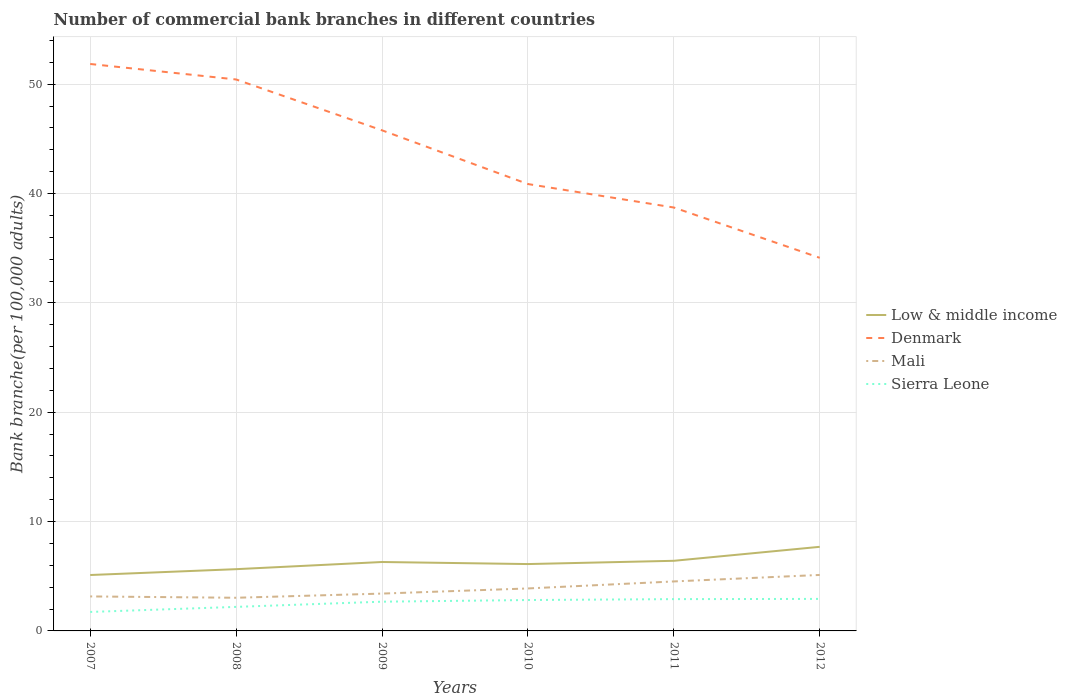How many different coloured lines are there?
Ensure brevity in your answer.  4. Does the line corresponding to Denmark intersect with the line corresponding to Sierra Leone?
Offer a terse response. No. Across all years, what is the maximum number of commercial bank branches in Denmark?
Your answer should be very brief. 34.12. In which year was the number of commercial bank branches in Low & middle income maximum?
Your response must be concise. 2007. What is the total number of commercial bank branches in Mali in the graph?
Your answer should be compact. -1.37. What is the difference between the highest and the second highest number of commercial bank branches in Sierra Leone?
Your answer should be very brief. 1.19. Is the number of commercial bank branches in Denmark strictly greater than the number of commercial bank branches in Low & middle income over the years?
Your answer should be very brief. No. How many lines are there?
Make the answer very short. 4. Are the values on the major ticks of Y-axis written in scientific E-notation?
Give a very brief answer. No. Does the graph contain any zero values?
Your answer should be very brief. No. How many legend labels are there?
Your answer should be very brief. 4. What is the title of the graph?
Provide a short and direct response. Number of commercial bank branches in different countries. Does "Cambodia" appear as one of the legend labels in the graph?
Your answer should be compact. No. What is the label or title of the X-axis?
Your response must be concise. Years. What is the label or title of the Y-axis?
Your answer should be compact. Bank branche(per 100,0 adults). What is the Bank branche(per 100,000 adults) of Low & middle income in 2007?
Your answer should be compact. 5.11. What is the Bank branche(per 100,000 adults) of Denmark in 2007?
Make the answer very short. 51.85. What is the Bank branche(per 100,000 adults) in Mali in 2007?
Give a very brief answer. 3.15. What is the Bank branche(per 100,000 adults) of Sierra Leone in 2007?
Offer a very short reply. 1.73. What is the Bank branche(per 100,000 adults) of Low & middle income in 2008?
Provide a short and direct response. 5.65. What is the Bank branche(per 100,000 adults) in Denmark in 2008?
Offer a very short reply. 50.43. What is the Bank branche(per 100,000 adults) in Mali in 2008?
Your answer should be very brief. 3.03. What is the Bank branche(per 100,000 adults) of Sierra Leone in 2008?
Offer a very short reply. 2.2. What is the Bank branche(per 100,000 adults) in Low & middle income in 2009?
Ensure brevity in your answer.  6.3. What is the Bank branche(per 100,000 adults) in Denmark in 2009?
Keep it short and to the point. 45.78. What is the Bank branche(per 100,000 adults) of Mali in 2009?
Offer a terse response. 3.42. What is the Bank branche(per 100,000 adults) in Sierra Leone in 2009?
Provide a succinct answer. 2.67. What is the Bank branche(per 100,000 adults) of Low & middle income in 2010?
Offer a very short reply. 6.11. What is the Bank branche(per 100,000 adults) of Denmark in 2010?
Make the answer very short. 40.87. What is the Bank branche(per 100,000 adults) in Mali in 2010?
Give a very brief answer. 3.88. What is the Bank branche(per 100,000 adults) in Sierra Leone in 2010?
Your answer should be very brief. 2.83. What is the Bank branche(per 100,000 adults) of Low & middle income in 2011?
Your answer should be very brief. 6.41. What is the Bank branche(per 100,000 adults) of Denmark in 2011?
Offer a terse response. 38.72. What is the Bank branche(per 100,000 adults) in Mali in 2011?
Your answer should be very brief. 4.52. What is the Bank branche(per 100,000 adults) of Sierra Leone in 2011?
Keep it short and to the point. 2.91. What is the Bank branche(per 100,000 adults) of Low & middle income in 2012?
Provide a succinct answer. 7.69. What is the Bank branche(per 100,000 adults) in Denmark in 2012?
Provide a short and direct response. 34.12. What is the Bank branche(per 100,000 adults) in Mali in 2012?
Your response must be concise. 5.12. What is the Bank branche(per 100,000 adults) in Sierra Leone in 2012?
Ensure brevity in your answer.  2.93. Across all years, what is the maximum Bank branche(per 100,000 adults) in Low & middle income?
Make the answer very short. 7.69. Across all years, what is the maximum Bank branche(per 100,000 adults) in Denmark?
Your response must be concise. 51.85. Across all years, what is the maximum Bank branche(per 100,000 adults) in Mali?
Provide a succinct answer. 5.12. Across all years, what is the maximum Bank branche(per 100,000 adults) of Sierra Leone?
Offer a very short reply. 2.93. Across all years, what is the minimum Bank branche(per 100,000 adults) of Low & middle income?
Your answer should be compact. 5.11. Across all years, what is the minimum Bank branche(per 100,000 adults) of Denmark?
Give a very brief answer. 34.12. Across all years, what is the minimum Bank branche(per 100,000 adults) of Mali?
Offer a very short reply. 3.03. Across all years, what is the minimum Bank branche(per 100,000 adults) of Sierra Leone?
Your answer should be compact. 1.73. What is the total Bank branche(per 100,000 adults) in Low & middle income in the graph?
Offer a terse response. 37.28. What is the total Bank branche(per 100,000 adults) in Denmark in the graph?
Make the answer very short. 261.77. What is the total Bank branche(per 100,000 adults) of Mali in the graph?
Make the answer very short. 23.13. What is the total Bank branche(per 100,000 adults) of Sierra Leone in the graph?
Provide a succinct answer. 15.27. What is the difference between the Bank branche(per 100,000 adults) in Low & middle income in 2007 and that in 2008?
Offer a terse response. -0.53. What is the difference between the Bank branche(per 100,000 adults) in Denmark in 2007 and that in 2008?
Your response must be concise. 1.42. What is the difference between the Bank branche(per 100,000 adults) in Mali in 2007 and that in 2008?
Your answer should be very brief. 0.12. What is the difference between the Bank branche(per 100,000 adults) in Sierra Leone in 2007 and that in 2008?
Make the answer very short. -0.46. What is the difference between the Bank branche(per 100,000 adults) in Low & middle income in 2007 and that in 2009?
Your answer should be compact. -1.19. What is the difference between the Bank branche(per 100,000 adults) in Denmark in 2007 and that in 2009?
Offer a very short reply. 6.07. What is the difference between the Bank branche(per 100,000 adults) of Mali in 2007 and that in 2009?
Ensure brevity in your answer.  -0.26. What is the difference between the Bank branche(per 100,000 adults) of Sierra Leone in 2007 and that in 2009?
Your answer should be very brief. -0.94. What is the difference between the Bank branche(per 100,000 adults) in Low & middle income in 2007 and that in 2010?
Your answer should be compact. -1. What is the difference between the Bank branche(per 100,000 adults) in Denmark in 2007 and that in 2010?
Your answer should be compact. 10.98. What is the difference between the Bank branche(per 100,000 adults) in Mali in 2007 and that in 2010?
Ensure brevity in your answer.  -0.73. What is the difference between the Bank branche(per 100,000 adults) in Sierra Leone in 2007 and that in 2010?
Provide a succinct answer. -1.09. What is the difference between the Bank branche(per 100,000 adults) of Low & middle income in 2007 and that in 2011?
Your answer should be compact. -1.3. What is the difference between the Bank branche(per 100,000 adults) in Denmark in 2007 and that in 2011?
Your answer should be very brief. 13.13. What is the difference between the Bank branche(per 100,000 adults) of Mali in 2007 and that in 2011?
Your answer should be compact. -1.37. What is the difference between the Bank branche(per 100,000 adults) in Sierra Leone in 2007 and that in 2011?
Ensure brevity in your answer.  -1.17. What is the difference between the Bank branche(per 100,000 adults) in Low & middle income in 2007 and that in 2012?
Provide a succinct answer. -2.58. What is the difference between the Bank branche(per 100,000 adults) in Denmark in 2007 and that in 2012?
Make the answer very short. 17.73. What is the difference between the Bank branche(per 100,000 adults) of Mali in 2007 and that in 2012?
Keep it short and to the point. -1.97. What is the difference between the Bank branche(per 100,000 adults) in Sierra Leone in 2007 and that in 2012?
Ensure brevity in your answer.  -1.19. What is the difference between the Bank branche(per 100,000 adults) in Low & middle income in 2008 and that in 2009?
Offer a terse response. -0.66. What is the difference between the Bank branche(per 100,000 adults) of Denmark in 2008 and that in 2009?
Keep it short and to the point. 4.65. What is the difference between the Bank branche(per 100,000 adults) in Mali in 2008 and that in 2009?
Provide a short and direct response. -0.38. What is the difference between the Bank branche(per 100,000 adults) of Sierra Leone in 2008 and that in 2009?
Make the answer very short. -0.48. What is the difference between the Bank branche(per 100,000 adults) of Low & middle income in 2008 and that in 2010?
Give a very brief answer. -0.47. What is the difference between the Bank branche(per 100,000 adults) of Denmark in 2008 and that in 2010?
Provide a succinct answer. 9.56. What is the difference between the Bank branche(per 100,000 adults) in Mali in 2008 and that in 2010?
Your answer should be compact. -0.85. What is the difference between the Bank branche(per 100,000 adults) in Sierra Leone in 2008 and that in 2010?
Keep it short and to the point. -0.63. What is the difference between the Bank branche(per 100,000 adults) of Low & middle income in 2008 and that in 2011?
Keep it short and to the point. -0.76. What is the difference between the Bank branche(per 100,000 adults) in Denmark in 2008 and that in 2011?
Your response must be concise. 11.71. What is the difference between the Bank branche(per 100,000 adults) in Mali in 2008 and that in 2011?
Give a very brief answer. -1.49. What is the difference between the Bank branche(per 100,000 adults) of Sierra Leone in 2008 and that in 2011?
Offer a terse response. -0.71. What is the difference between the Bank branche(per 100,000 adults) of Low & middle income in 2008 and that in 2012?
Offer a terse response. -2.04. What is the difference between the Bank branche(per 100,000 adults) in Denmark in 2008 and that in 2012?
Ensure brevity in your answer.  16.31. What is the difference between the Bank branche(per 100,000 adults) of Mali in 2008 and that in 2012?
Offer a terse response. -2.09. What is the difference between the Bank branche(per 100,000 adults) in Sierra Leone in 2008 and that in 2012?
Provide a short and direct response. -0.73. What is the difference between the Bank branche(per 100,000 adults) in Low & middle income in 2009 and that in 2010?
Give a very brief answer. 0.19. What is the difference between the Bank branche(per 100,000 adults) of Denmark in 2009 and that in 2010?
Offer a very short reply. 4.91. What is the difference between the Bank branche(per 100,000 adults) of Mali in 2009 and that in 2010?
Your response must be concise. -0.47. What is the difference between the Bank branche(per 100,000 adults) in Sierra Leone in 2009 and that in 2010?
Provide a short and direct response. -0.15. What is the difference between the Bank branche(per 100,000 adults) in Low & middle income in 2009 and that in 2011?
Provide a succinct answer. -0.11. What is the difference between the Bank branche(per 100,000 adults) of Denmark in 2009 and that in 2011?
Give a very brief answer. 7.06. What is the difference between the Bank branche(per 100,000 adults) in Mali in 2009 and that in 2011?
Your answer should be very brief. -1.11. What is the difference between the Bank branche(per 100,000 adults) in Sierra Leone in 2009 and that in 2011?
Your response must be concise. -0.23. What is the difference between the Bank branche(per 100,000 adults) of Low & middle income in 2009 and that in 2012?
Your answer should be very brief. -1.39. What is the difference between the Bank branche(per 100,000 adults) of Denmark in 2009 and that in 2012?
Provide a succinct answer. 11.66. What is the difference between the Bank branche(per 100,000 adults) of Mali in 2009 and that in 2012?
Your answer should be very brief. -1.7. What is the difference between the Bank branche(per 100,000 adults) of Sierra Leone in 2009 and that in 2012?
Make the answer very short. -0.25. What is the difference between the Bank branche(per 100,000 adults) of Low & middle income in 2010 and that in 2011?
Give a very brief answer. -0.3. What is the difference between the Bank branche(per 100,000 adults) of Denmark in 2010 and that in 2011?
Keep it short and to the point. 2.15. What is the difference between the Bank branche(per 100,000 adults) in Mali in 2010 and that in 2011?
Your answer should be compact. -0.64. What is the difference between the Bank branche(per 100,000 adults) in Sierra Leone in 2010 and that in 2011?
Provide a short and direct response. -0.08. What is the difference between the Bank branche(per 100,000 adults) in Low & middle income in 2010 and that in 2012?
Your answer should be very brief. -1.58. What is the difference between the Bank branche(per 100,000 adults) in Denmark in 2010 and that in 2012?
Make the answer very short. 6.75. What is the difference between the Bank branche(per 100,000 adults) of Mali in 2010 and that in 2012?
Give a very brief answer. -1.24. What is the difference between the Bank branche(per 100,000 adults) of Sierra Leone in 2010 and that in 2012?
Offer a terse response. -0.1. What is the difference between the Bank branche(per 100,000 adults) in Low & middle income in 2011 and that in 2012?
Offer a very short reply. -1.28. What is the difference between the Bank branche(per 100,000 adults) in Denmark in 2011 and that in 2012?
Give a very brief answer. 4.6. What is the difference between the Bank branche(per 100,000 adults) of Mali in 2011 and that in 2012?
Provide a succinct answer. -0.59. What is the difference between the Bank branche(per 100,000 adults) in Sierra Leone in 2011 and that in 2012?
Your answer should be compact. -0.02. What is the difference between the Bank branche(per 100,000 adults) of Low & middle income in 2007 and the Bank branche(per 100,000 adults) of Denmark in 2008?
Your response must be concise. -45.32. What is the difference between the Bank branche(per 100,000 adults) of Low & middle income in 2007 and the Bank branche(per 100,000 adults) of Mali in 2008?
Your response must be concise. 2.08. What is the difference between the Bank branche(per 100,000 adults) in Low & middle income in 2007 and the Bank branche(per 100,000 adults) in Sierra Leone in 2008?
Your answer should be very brief. 2.91. What is the difference between the Bank branche(per 100,000 adults) of Denmark in 2007 and the Bank branche(per 100,000 adults) of Mali in 2008?
Offer a terse response. 48.82. What is the difference between the Bank branche(per 100,000 adults) of Denmark in 2007 and the Bank branche(per 100,000 adults) of Sierra Leone in 2008?
Offer a terse response. 49.65. What is the difference between the Bank branche(per 100,000 adults) in Mali in 2007 and the Bank branche(per 100,000 adults) in Sierra Leone in 2008?
Offer a very short reply. 0.96. What is the difference between the Bank branche(per 100,000 adults) in Low & middle income in 2007 and the Bank branche(per 100,000 adults) in Denmark in 2009?
Give a very brief answer. -40.67. What is the difference between the Bank branche(per 100,000 adults) in Low & middle income in 2007 and the Bank branche(per 100,000 adults) in Mali in 2009?
Provide a short and direct response. 1.7. What is the difference between the Bank branche(per 100,000 adults) of Low & middle income in 2007 and the Bank branche(per 100,000 adults) of Sierra Leone in 2009?
Your answer should be very brief. 2.44. What is the difference between the Bank branche(per 100,000 adults) in Denmark in 2007 and the Bank branche(per 100,000 adults) in Mali in 2009?
Your response must be concise. 48.43. What is the difference between the Bank branche(per 100,000 adults) in Denmark in 2007 and the Bank branche(per 100,000 adults) in Sierra Leone in 2009?
Offer a very short reply. 49.18. What is the difference between the Bank branche(per 100,000 adults) of Mali in 2007 and the Bank branche(per 100,000 adults) of Sierra Leone in 2009?
Provide a short and direct response. 0.48. What is the difference between the Bank branche(per 100,000 adults) of Low & middle income in 2007 and the Bank branche(per 100,000 adults) of Denmark in 2010?
Offer a very short reply. -35.76. What is the difference between the Bank branche(per 100,000 adults) of Low & middle income in 2007 and the Bank branche(per 100,000 adults) of Mali in 2010?
Offer a terse response. 1.23. What is the difference between the Bank branche(per 100,000 adults) in Low & middle income in 2007 and the Bank branche(per 100,000 adults) in Sierra Leone in 2010?
Make the answer very short. 2.29. What is the difference between the Bank branche(per 100,000 adults) in Denmark in 2007 and the Bank branche(per 100,000 adults) in Mali in 2010?
Keep it short and to the point. 47.96. What is the difference between the Bank branche(per 100,000 adults) in Denmark in 2007 and the Bank branche(per 100,000 adults) in Sierra Leone in 2010?
Offer a terse response. 49.02. What is the difference between the Bank branche(per 100,000 adults) in Mali in 2007 and the Bank branche(per 100,000 adults) in Sierra Leone in 2010?
Provide a succinct answer. 0.33. What is the difference between the Bank branche(per 100,000 adults) in Low & middle income in 2007 and the Bank branche(per 100,000 adults) in Denmark in 2011?
Your response must be concise. -33.61. What is the difference between the Bank branche(per 100,000 adults) in Low & middle income in 2007 and the Bank branche(per 100,000 adults) in Mali in 2011?
Your response must be concise. 0.59. What is the difference between the Bank branche(per 100,000 adults) in Low & middle income in 2007 and the Bank branche(per 100,000 adults) in Sierra Leone in 2011?
Keep it short and to the point. 2.2. What is the difference between the Bank branche(per 100,000 adults) in Denmark in 2007 and the Bank branche(per 100,000 adults) in Mali in 2011?
Provide a short and direct response. 47.32. What is the difference between the Bank branche(per 100,000 adults) of Denmark in 2007 and the Bank branche(per 100,000 adults) of Sierra Leone in 2011?
Offer a terse response. 48.94. What is the difference between the Bank branche(per 100,000 adults) of Mali in 2007 and the Bank branche(per 100,000 adults) of Sierra Leone in 2011?
Your answer should be very brief. 0.25. What is the difference between the Bank branche(per 100,000 adults) in Low & middle income in 2007 and the Bank branche(per 100,000 adults) in Denmark in 2012?
Give a very brief answer. -29.01. What is the difference between the Bank branche(per 100,000 adults) of Low & middle income in 2007 and the Bank branche(per 100,000 adults) of Mali in 2012?
Offer a terse response. -0.01. What is the difference between the Bank branche(per 100,000 adults) in Low & middle income in 2007 and the Bank branche(per 100,000 adults) in Sierra Leone in 2012?
Your response must be concise. 2.18. What is the difference between the Bank branche(per 100,000 adults) in Denmark in 2007 and the Bank branche(per 100,000 adults) in Mali in 2012?
Your response must be concise. 46.73. What is the difference between the Bank branche(per 100,000 adults) of Denmark in 2007 and the Bank branche(per 100,000 adults) of Sierra Leone in 2012?
Your answer should be compact. 48.92. What is the difference between the Bank branche(per 100,000 adults) in Mali in 2007 and the Bank branche(per 100,000 adults) in Sierra Leone in 2012?
Offer a terse response. 0.23. What is the difference between the Bank branche(per 100,000 adults) in Low & middle income in 2008 and the Bank branche(per 100,000 adults) in Denmark in 2009?
Keep it short and to the point. -40.13. What is the difference between the Bank branche(per 100,000 adults) of Low & middle income in 2008 and the Bank branche(per 100,000 adults) of Mali in 2009?
Keep it short and to the point. 2.23. What is the difference between the Bank branche(per 100,000 adults) of Low & middle income in 2008 and the Bank branche(per 100,000 adults) of Sierra Leone in 2009?
Your answer should be compact. 2.97. What is the difference between the Bank branche(per 100,000 adults) in Denmark in 2008 and the Bank branche(per 100,000 adults) in Mali in 2009?
Make the answer very short. 47.02. What is the difference between the Bank branche(per 100,000 adults) of Denmark in 2008 and the Bank branche(per 100,000 adults) of Sierra Leone in 2009?
Give a very brief answer. 47.76. What is the difference between the Bank branche(per 100,000 adults) in Mali in 2008 and the Bank branche(per 100,000 adults) in Sierra Leone in 2009?
Ensure brevity in your answer.  0.36. What is the difference between the Bank branche(per 100,000 adults) of Low & middle income in 2008 and the Bank branche(per 100,000 adults) of Denmark in 2010?
Your answer should be compact. -35.22. What is the difference between the Bank branche(per 100,000 adults) of Low & middle income in 2008 and the Bank branche(per 100,000 adults) of Mali in 2010?
Make the answer very short. 1.76. What is the difference between the Bank branche(per 100,000 adults) of Low & middle income in 2008 and the Bank branche(per 100,000 adults) of Sierra Leone in 2010?
Your answer should be compact. 2.82. What is the difference between the Bank branche(per 100,000 adults) in Denmark in 2008 and the Bank branche(per 100,000 adults) in Mali in 2010?
Provide a short and direct response. 46.55. What is the difference between the Bank branche(per 100,000 adults) in Denmark in 2008 and the Bank branche(per 100,000 adults) in Sierra Leone in 2010?
Make the answer very short. 47.61. What is the difference between the Bank branche(per 100,000 adults) of Mali in 2008 and the Bank branche(per 100,000 adults) of Sierra Leone in 2010?
Your answer should be compact. 0.21. What is the difference between the Bank branche(per 100,000 adults) in Low & middle income in 2008 and the Bank branche(per 100,000 adults) in Denmark in 2011?
Keep it short and to the point. -33.07. What is the difference between the Bank branche(per 100,000 adults) of Low & middle income in 2008 and the Bank branche(per 100,000 adults) of Mali in 2011?
Your response must be concise. 1.12. What is the difference between the Bank branche(per 100,000 adults) of Low & middle income in 2008 and the Bank branche(per 100,000 adults) of Sierra Leone in 2011?
Provide a succinct answer. 2.74. What is the difference between the Bank branche(per 100,000 adults) of Denmark in 2008 and the Bank branche(per 100,000 adults) of Mali in 2011?
Offer a terse response. 45.91. What is the difference between the Bank branche(per 100,000 adults) in Denmark in 2008 and the Bank branche(per 100,000 adults) in Sierra Leone in 2011?
Your answer should be very brief. 47.52. What is the difference between the Bank branche(per 100,000 adults) of Mali in 2008 and the Bank branche(per 100,000 adults) of Sierra Leone in 2011?
Offer a terse response. 0.12. What is the difference between the Bank branche(per 100,000 adults) in Low & middle income in 2008 and the Bank branche(per 100,000 adults) in Denmark in 2012?
Give a very brief answer. -28.47. What is the difference between the Bank branche(per 100,000 adults) in Low & middle income in 2008 and the Bank branche(per 100,000 adults) in Mali in 2012?
Your answer should be compact. 0.53. What is the difference between the Bank branche(per 100,000 adults) of Low & middle income in 2008 and the Bank branche(per 100,000 adults) of Sierra Leone in 2012?
Your response must be concise. 2.72. What is the difference between the Bank branche(per 100,000 adults) of Denmark in 2008 and the Bank branche(per 100,000 adults) of Mali in 2012?
Provide a succinct answer. 45.31. What is the difference between the Bank branche(per 100,000 adults) of Denmark in 2008 and the Bank branche(per 100,000 adults) of Sierra Leone in 2012?
Make the answer very short. 47.5. What is the difference between the Bank branche(per 100,000 adults) in Mali in 2008 and the Bank branche(per 100,000 adults) in Sierra Leone in 2012?
Your answer should be compact. 0.1. What is the difference between the Bank branche(per 100,000 adults) in Low & middle income in 2009 and the Bank branche(per 100,000 adults) in Denmark in 2010?
Ensure brevity in your answer.  -34.57. What is the difference between the Bank branche(per 100,000 adults) in Low & middle income in 2009 and the Bank branche(per 100,000 adults) in Mali in 2010?
Ensure brevity in your answer.  2.42. What is the difference between the Bank branche(per 100,000 adults) in Low & middle income in 2009 and the Bank branche(per 100,000 adults) in Sierra Leone in 2010?
Your answer should be compact. 3.48. What is the difference between the Bank branche(per 100,000 adults) in Denmark in 2009 and the Bank branche(per 100,000 adults) in Mali in 2010?
Offer a terse response. 41.9. What is the difference between the Bank branche(per 100,000 adults) in Denmark in 2009 and the Bank branche(per 100,000 adults) in Sierra Leone in 2010?
Ensure brevity in your answer.  42.96. What is the difference between the Bank branche(per 100,000 adults) of Mali in 2009 and the Bank branche(per 100,000 adults) of Sierra Leone in 2010?
Provide a succinct answer. 0.59. What is the difference between the Bank branche(per 100,000 adults) in Low & middle income in 2009 and the Bank branche(per 100,000 adults) in Denmark in 2011?
Make the answer very short. -32.42. What is the difference between the Bank branche(per 100,000 adults) of Low & middle income in 2009 and the Bank branche(per 100,000 adults) of Mali in 2011?
Your answer should be compact. 1.78. What is the difference between the Bank branche(per 100,000 adults) in Low & middle income in 2009 and the Bank branche(per 100,000 adults) in Sierra Leone in 2011?
Provide a succinct answer. 3.39. What is the difference between the Bank branche(per 100,000 adults) of Denmark in 2009 and the Bank branche(per 100,000 adults) of Mali in 2011?
Your answer should be very brief. 41.26. What is the difference between the Bank branche(per 100,000 adults) of Denmark in 2009 and the Bank branche(per 100,000 adults) of Sierra Leone in 2011?
Give a very brief answer. 42.87. What is the difference between the Bank branche(per 100,000 adults) of Mali in 2009 and the Bank branche(per 100,000 adults) of Sierra Leone in 2011?
Keep it short and to the point. 0.51. What is the difference between the Bank branche(per 100,000 adults) of Low & middle income in 2009 and the Bank branche(per 100,000 adults) of Denmark in 2012?
Provide a short and direct response. -27.82. What is the difference between the Bank branche(per 100,000 adults) of Low & middle income in 2009 and the Bank branche(per 100,000 adults) of Mali in 2012?
Keep it short and to the point. 1.18. What is the difference between the Bank branche(per 100,000 adults) of Low & middle income in 2009 and the Bank branche(per 100,000 adults) of Sierra Leone in 2012?
Your response must be concise. 3.37. What is the difference between the Bank branche(per 100,000 adults) of Denmark in 2009 and the Bank branche(per 100,000 adults) of Mali in 2012?
Offer a very short reply. 40.66. What is the difference between the Bank branche(per 100,000 adults) of Denmark in 2009 and the Bank branche(per 100,000 adults) of Sierra Leone in 2012?
Provide a short and direct response. 42.85. What is the difference between the Bank branche(per 100,000 adults) in Mali in 2009 and the Bank branche(per 100,000 adults) in Sierra Leone in 2012?
Give a very brief answer. 0.49. What is the difference between the Bank branche(per 100,000 adults) in Low & middle income in 2010 and the Bank branche(per 100,000 adults) in Denmark in 2011?
Your answer should be compact. -32.61. What is the difference between the Bank branche(per 100,000 adults) in Low & middle income in 2010 and the Bank branche(per 100,000 adults) in Mali in 2011?
Keep it short and to the point. 1.59. What is the difference between the Bank branche(per 100,000 adults) in Low & middle income in 2010 and the Bank branche(per 100,000 adults) in Sierra Leone in 2011?
Your answer should be very brief. 3.21. What is the difference between the Bank branche(per 100,000 adults) in Denmark in 2010 and the Bank branche(per 100,000 adults) in Mali in 2011?
Keep it short and to the point. 36.34. What is the difference between the Bank branche(per 100,000 adults) of Denmark in 2010 and the Bank branche(per 100,000 adults) of Sierra Leone in 2011?
Provide a succinct answer. 37.96. What is the difference between the Bank branche(per 100,000 adults) in Mali in 2010 and the Bank branche(per 100,000 adults) in Sierra Leone in 2011?
Your answer should be compact. 0.98. What is the difference between the Bank branche(per 100,000 adults) of Low & middle income in 2010 and the Bank branche(per 100,000 adults) of Denmark in 2012?
Make the answer very short. -28.01. What is the difference between the Bank branche(per 100,000 adults) of Low & middle income in 2010 and the Bank branche(per 100,000 adults) of Sierra Leone in 2012?
Keep it short and to the point. 3.19. What is the difference between the Bank branche(per 100,000 adults) of Denmark in 2010 and the Bank branche(per 100,000 adults) of Mali in 2012?
Your answer should be compact. 35.75. What is the difference between the Bank branche(per 100,000 adults) of Denmark in 2010 and the Bank branche(per 100,000 adults) of Sierra Leone in 2012?
Provide a short and direct response. 37.94. What is the difference between the Bank branche(per 100,000 adults) of Mali in 2010 and the Bank branche(per 100,000 adults) of Sierra Leone in 2012?
Ensure brevity in your answer.  0.96. What is the difference between the Bank branche(per 100,000 adults) of Low & middle income in 2011 and the Bank branche(per 100,000 adults) of Denmark in 2012?
Keep it short and to the point. -27.71. What is the difference between the Bank branche(per 100,000 adults) in Low & middle income in 2011 and the Bank branche(per 100,000 adults) in Mali in 2012?
Your answer should be very brief. 1.29. What is the difference between the Bank branche(per 100,000 adults) in Low & middle income in 2011 and the Bank branche(per 100,000 adults) in Sierra Leone in 2012?
Provide a short and direct response. 3.48. What is the difference between the Bank branche(per 100,000 adults) of Denmark in 2011 and the Bank branche(per 100,000 adults) of Mali in 2012?
Your answer should be compact. 33.6. What is the difference between the Bank branche(per 100,000 adults) in Denmark in 2011 and the Bank branche(per 100,000 adults) in Sierra Leone in 2012?
Provide a succinct answer. 35.79. What is the difference between the Bank branche(per 100,000 adults) of Mali in 2011 and the Bank branche(per 100,000 adults) of Sierra Leone in 2012?
Your answer should be compact. 1.6. What is the average Bank branche(per 100,000 adults) of Low & middle income per year?
Offer a terse response. 6.21. What is the average Bank branche(per 100,000 adults) in Denmark per year?
Your response must be concise. 43.63. What is the average Bank branche(per 100,000 adults) of Mali per year?
Your answer should be very brief. 3.86. What is the average Bank branche(per 100,000 adults) of Sierra Leone per year?
Your response must be concise. 2.54. In the year 2007, what is the difference between the Bank branche(per 100,000 adults) of Low & middle income and Bank branche(per 100,000 adults) of Denmark?
Make the answer very short. -46.74. In the year 2007, what is the difference between the Bank branche(per 100,000 adults) of Low & middle income and Bank branche(per 100,000 adults) of Mali?
Your response must be concise. 1.96. In the year 2007, what is the difference between the Bank branche(per 100,000 adults) of Low & middle income and Bank branche(per 100,000 adults) of Sierra Leone?
Offer a terse response. 3.38. In the year 2007, what is the difference between the Bank branche(per 100,000 adults) in Denmark and Bank branche(per 100,000 adults) in Mali?
Your answer should be very brief. 48.69. In the year 2007, what is the difference between the Bank branche(per 100,000 adults) of Denmark and Bank branche(per 100,000 adults) of Sierra Leone?
Make the answer very short. 50.11. In the year 2007, what is the difference between the Bank branche(per 100,000 adults) of Mali and Bank branche(per 100,000 adults) of Sierra Leone?
Give a very brief answer. 1.42. In the year 2008, what is the difference between the Bank branche(per 100,000 adults) in Low & middle income and Bank branche(per 100,000 adults) in Denmark?
Provide a short and direct response. -44.78. In the year 2008, what is the difference between the Bank branche(per 100,000 adults) in Low & middle income and Bank branche(per 100,000 adults) in Mali?
Ensure brevity in your answer.  2.61. In the year 2008, what is the difference between the Bank branche(per 100,000 adults) in Low & middle income and Bank branche(per 100,000 adults) in Sierra Leone?
Provide a short and direct response. 3.45. In the year 2008, what is the difference between the Bank branche(per 100,000 adults) of Denmark and Bank branche(per 100,000 adults) of Mali?
Provide a succinct answer. 47.4. In the year 2008, what is the difference between the Bank branche(per 100,000 adults) of Denmark and Bank branche(per 100,000 adults) of Sierra Leone?
Your answer should be compact. 48.23. In the year 2008, what is the difference between the Bank branche(per 100,000 adults) in Mali and Bank branche(per 100,000 adults) in Sierra Leone?
Provide a short and direct response. 0.83. In the year 2009, what is the difference between the Bank branche(per 100,000 adults) of Low & middle income and Bank branche(per 100,000 adults) of Denmark?
Make the answer very short. -39.48. In the year 2009, what is the difference between the Bank branche(per 100,000 adults) in Low & middle income and Bank branche(per 100,000 adults) in Mali?
Provide a succinct answer. 2.89. In the year 2009, what is the difference between the Bank branche(per 100,000 adults) in Low & middle income and Bank branche(per 100,000 adults) in Sierra Leone?
Your answer should be very brief. 3.63. In the year 2009, what is the difference between the Bank branche(per 100,000 adults) of Denmark and Bank branche(per 100,000 adults) of Mali?
Give a very brief answer. 42.37. In the year 2009, what is the difference between the Bank branche(per 100,000 adults) of Denmark and Bank branche(per 100,000 adults) of Sierra Leone?
Offer a terse response. 43.11. In the year 2009, what is the difference between the Bank branche(per 100,000 adults) in Mali and Bank branche(per 100,000 adults) in Sierra Leone?
Provide a short and direct response. 0.74. In the year 2010, what is the difference between the Bank branche(per 100,000 adults) in Low & middle income and Bank branche(per 100,000 adults) in Denmark?
Give a very brief answer. -34.75. In the year 2010, what is the difference between the Bank branche(per 100,000 adults) of Low & middle income and Bank branche(per 100,000 adults) of Mali?
Your answer should be compact. 2.23. In the year 2010, what is the difference between the Bank branche(per 100,000 adults) in Low & middle income and Bank branche(per 100,000 adults) in Sierra Leone?
Ensure brevity in your answer.  3.29. In the year 2010, what is the difference between the Bank branche(per 100,000 adults) of Denmark and Bank branche(per 100,000 adults) of Mali?
Provide a short and direct response. 36.98. In the year 2010, what is the difference between the Bank branche(per 100,000 adults) of Denmark and Bank branche(per 100,000 adults) of Sierra Leone?
Provide a succinct answer. 38.04. In the year 2010, what is the difference between the Bank branche(per 100,000 adults) of Mali and Bank branche(per 100,000 adults) of Sierra Leone?
Give a very brief answer. 1.06. In the year 2011, what is the difference between the Bank branche(per 100,000 adults) of Low & middle income and Bank branche(per 100,000 adults) of Denmark?
Offer a very short reply. -32.31. In the year 2011, what is the difference between the Bank branche(per 100,000 adults) in Low & middle income and Bank branche(per 100,000 adults) in Mali?
Offer a very short reply. 1.89. In the year 2011, what is the difference between the Bank branche(per 100,000 adults) in Low & middle income and Bank branche(per 100,000 adults) in Sierra Leone?
Your response must be concise. 3.5. In the year 2011, what is the difference between the Bank branche(per 100,000 adults) in Denmark and Bank branche(per 100,000 adults) in Mali?
Make the answer very short. 34.2. In the year 2011, what is the difference between the Bank branche(per 100,000 adults) of Denmark and Bank branche(per 100,000 adults) of Sierra Leone?
Ensure brevity in your answer.  35.81. In the year 2011, what is the difference between the Bank branche(per 100,000 adults) of Mali and Bank branche(per 100,000 adults) of Sierra Leone?
Give a very brief answer. 1.62. In the year 2012, what is the difference between the Bank branche(per 100,000 adults) in Low & middle income and Bank branche(per 100,000 adults) in Denmark?
Ensure brevity in your answer.  -26.43. In the year 2012, what is the difference between the Bank branche(per 100,000 adults) in Low & middle income and Bank branche(per 100,000 adults) in Mali?
Make the answer very short. 2.57. In the year 2012, what is the difference between the Bank branche(per 100,000 adults) of Low & middle income and Bank branche(per 100,000 adults) of Sierra Leone?
Offer a very short reply. 4.76. In the year 2012, what is the difference between the Bank branche(per 100,000 adults) in Denmark and Bank branche(per 100,000 adults) in Mali?
Your response must be concise. 29. In the year 2012, what is the difference between the Bank branche(per 100,000 adults) in Denmark and Bank branche(per 100,000 adults) in Sierra Leone?
Provide a succinct answer. 31.19. In the year 2012, what is the difference between the Bank branche(per 100,000 adults) in Mali and Bank branche(per 100,000 adults) in Sierra Leone?
Ensure brevity in your answer.  2.19. What is the ratio of the Bank branche(per 100,000 adults) in Low & middle income in 2007 to that in 2008?
Your answer should be compact. 0.91. What is the ratio of the Bank branche(per 100,000 adults) of Denmark in 2007 to that in 2008?
Provide a short and direct response. 1.03. What is the ratio of the Bank branche(per 100,000 adults) in Mali in 2007 to that in 2008?
Make the answer very short. 1.04. What is the ratio of the Bank branche(per 100,000 adults) in Sierra Leone in 2007 to that in 2008?
Your answer should be compact. 0.79. What is the ratio of the Bank branche(per 100,000 adults) of Low & middle income in 2007 to that in 2009?
Make the answer very short. 0.81. What is the ratio of the Bank branche(per 100,000 adults) of Denmark in 2007 to that in 2009?
Your answer should be very brief. 1.13. What is the ratio of the Bank branche(per 100,000 adults) in Mali in 2007 to that in 2009?
Keep it short and to the point. 0.92. What is the ratio of the Bank branche(per 100,000 adults) of Sierra Leone in 2007 to that in 2009?
Your answer should be compact. 0.65. What is the ratio of the Bank branche(per 100,000 adults) of Low & middle income in 2007 to that in 2010?
Your answer should be very brief. 0.84. What is the ratio of the Bank branche(per 100,000 adults) of Denmark in 2007 to that in 2010?
Give a very brief answer. 1.27. What is the ratio of the Bank branche(per 100,000 adults) of Mali in 2007 to that in 2010?
Provide a succinct answer. 0.81. What is the ratio of the Bank branche(per 100,000 adults) in Sierra Leone in 2007 to that in 2010?
Your response must be concise. 0.61. What is the ratio of the Bank branche(per 100,000 adults) of Low & middle income in 2007 to that in 2011?
Keep it short and to the point. 0.8. What is the ratio of the Bank branche(per 100,000 adults) of Denmark in 2007 to that in 2011?
Your answer should be compact. 1.34. What is the ratio of the Bank branche(per 100,000 adults) in Mali in 2007 to that in 2011?
Provide a short and direct response. 0.7. What is the ratio of the Bank branche(per 100,000 adults) of Sierra Leone in 2007 to that in 2011?
Offer a very short reply. 0.6. What is the ratio of the Bank branche(per 100,000 adults) in Low & middle income in 2007 to that in 2012?
Keep it short and to the point. 0.66. What is the ratio of the Bank branche(per 100,000 adults) of Denmark in 2007 to that in 2012?
Offer a terse response. 1.52. What is the ratio of the Bank branche(per 100,000 adults) in Mali in 2007 to that in 2012?
Give a very brief answer. 0.62. What is the ratio of the Bank branche(per 100,000 adults) of Sierra Leone in 2007 to that in 2012?
Keep it short and to the point. 0.59. What is the ratio of the Bank branche(per 100,000 adults) in Low & middle income in 2008 to that in 2009?
Your answer should be compact. 0.9. What is the ratio of the Bank branche(per 100,000 adults) of Denmark in 2008 to that in 2009?
Provide a succinct answer. 1.1. What is the ratio of the Bank branche(per 100,000 adults) in Mali in 2008 to that in 2009?
Your response must be concise. 0.89. What is the ratio of the Bank branche(per 100,000 adults) in Sierra Leone in 2008 to that in 2009?
Make the answer very short. 0.82. What is the ratio of the Bank branche(per 100,000 adults) in Low & middle income in 2008 to that in 2010?
Provide a succinct answer. 0.92. What is the ratio of the Bank branche(per 100,000 adults) of Denmark in 2008 to that in 2010?
Your answer should be very brief. 1.23. What is the ratio of the Bank branche(per 100,000 adults) of Mali in 2008 to that in 2010?
Give a very brief answer. 0.78. What is the ratio of the Bank branche(per 100,000 adults) of Sierra Leone in 2008 to that in 2010?
Provide a short and direct response. 0.78. What is the ratio of the Bank branche(per 100,000 adults) of Low & middle income in 2008 to that in 2011?
Ensure brevity in your answer.  0.88. What is the ratio of the Bank branche(per 100,000 adults) of Denmark in 2008 to that in 2011?
Your answer should be very brief. 1.3. What is the ratio of the Bank branche(per 100,000 adults) of Mali in 2008 to that in 2011?
Make the answer very short. 0.67. What is the ratio of the Bank branche(per 100,000 adults) in Sierra Leone in 2008 to that in 2011?
Your response must be concise. 0.76. What is the ratio of the Bank branche(per 100,000 adults) of Low & middle income in 2008 to that in 2012?
Provide a succinct answer. 0.73. What is the ratio of the Bank branche(per 100,000 adults) in Denmark in 2008 to that in 2012?
Make the answer very short. 1.48. What is the ratio of the Bank branche(per 100,000 adults) in Mali in 2008 to that in 2012?
Provide a short and direct response. 0.59. What is the ratio of the Bank branche(per 100,000 adults) in Sierra Leone in 2008 to that in 2012?
Offer a very short reply. 0.75. What is the ratio of the Bank branche(per 100,000 adults) of Low & middle income in 2009 to that in 2010?
Offer a terse response. 1.03. What is the ratio of the Bank branche(per 100,000 adults) of Denmark in 2009 to that in 2010?
Provide a short and direct response. 1.12. What is the ratio of the Bank branche(per 100,000 adults) in Mali in 2009 to that in 2010?
Offer a terse response. 0.88. What is the ratio of the Bank branche(per 100,000 adults) in Sierra Leone in 2009 to that in 2010?
Your response must be concise. 0.95. What is the ratio of the Bank branche(per 100,000 adults) of Low & middle income in 2009 to that in 2011?
Ensure brevity in your answer.  0.98. What is the ratio of the Bank branche(per 100,000 adults) of Denmark in 2009 to that in 2011?
Your answer should be very brief. 1.18. What is the ratio of the Bank branche(per 100,000 adults) of Mali in 2009 to that in 2011?
Give a very brief answer. 0.75. What is the ratio of the Bank branche(per 100,000 adults) of Sierra Leone in 2009 to that in 2011?
Your answer should be very brief. 0.92. What is the ratio of the Bank branche(per 100,000 adults) of Low & middle income in 2009 to that in 2012?
Give a very brief answer. 0.82. What is the ratio of the Bank branche(per 100,000 adults) in Denmark in 2009 to that in 2012?
Offer a very short reply. 1.34. What is the ratio of the Bank branche(per 100,000 adults) in Mali in 2009 to that in 2012?
Make the answer very short. 0.67. What is the ratio of the Bank branche(per 100,000 adults) of Sierra Leone in 2009 to that in 2012?
Keep it short and to the point. 0.91. What is the ratio of the Bank branche(per 100,000 adults) of Low & middle income in 2010 to that in 2011?
Provide a short and direct response. 0.95. What is the ratio of the Bank branche(per 100,000 adults) in Denmark in 2010 to that in 2011?
Give a very brief answer. 1.06. What is the ratio of the Bank branche(per 100,000 adults) of Mali in 2010 to that in 2011?
Provide a succinct answer. 0.86. What is the ratio of the Bank branche(per 100,000 adults) of Sierra Leone in 2010 to that in 2011?
Provide a short and direct response. 0.97. What is the ratio of the Bank branche(per 100,000 adults) of Low & middle income in 2010 to that in 2012?
Give a very brief answer. 0.79. What is the ratio of the Bank branche(per 100,000 adults) in Denmark in 2010 to that in 2012?
Offer a terse response. 1.2. What is the ratio of the Bank branche(per 100,000 adults) of Mali in 2010 to that in 2012?
Your answer should be compact. 0.76. What is the ratio of the Bank branche(per 100,000 adults) of Sierra Leone in 2010 to that in 2012?
Provide a short and direct response. 0.96. What is the ratio of the Bank branche(per 100,000 adults) in Low & middle income in 2011 to that in 2012?
Make the answer very short. 0.83. What is the ratio of the Bank branche(per 100,000 adults) in Denmark in 2011 to that in 2012?
Provide a succinct answer. 1.13. What is the ratio of the Bank branche(per 100,000 adults) in Mali in 2011 to that in 2012?
Your response must be concise. 0.88. What is the ratio of the Bank branche(per 100,000 adults) in Sierra Leone in 2011 to that in 2012?
Your answer should be very brief. 0.99. What is the difference between the highest and the second highest Bank branche(per 100,000 adults) in Low & middle income?
Give a very brief answer. 1.28. What is the difference between the highest and the second highest Bank branche(per 100,000 adults) of Denmark?
Give a very brief answer. 1.42. What is the difference between the highest and the second highest Bank branche(per 100,000 adults) in Mali?
Provide a short and direct response. 0.59. What is the difference between the highest and the second highest Bank branche(per 100,000 adults) of Sierra Leone?
Ensure brevity in your answer.  0.02. What is the difference between the highest and the lowest Bank branche(per 100,000 adults) of Low & middle income?
Your response must be concise. 2.58. What is the difference between the highest and the lowest Bank branche(per 100,000 adults) in Denmark?
Keep it short and to the point. 17.73. What is the difference between the highest and the lowest Bank branche(per 100,000 adults) of Mali?
Your response must be concise. 2.09. What is the difference between the highest and the lowest Bank branche(per 100,000 adults) in Sierra Leone?
Provide a short and direct response. 1.19. 